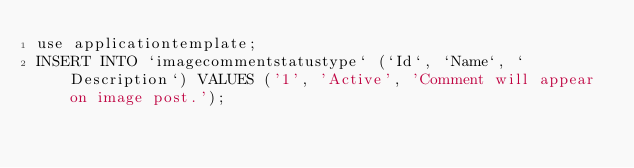Convert code to text. <code><loc_0><loc_0><loc_500><loc_500><_SQL_>use applicationtemplate;
INSERT INTO `imagecommentstatustype` (`Id`, `Name`, `Description`) VALUES ('1', 'Active', 'Comment will appear on image post.');</code> 